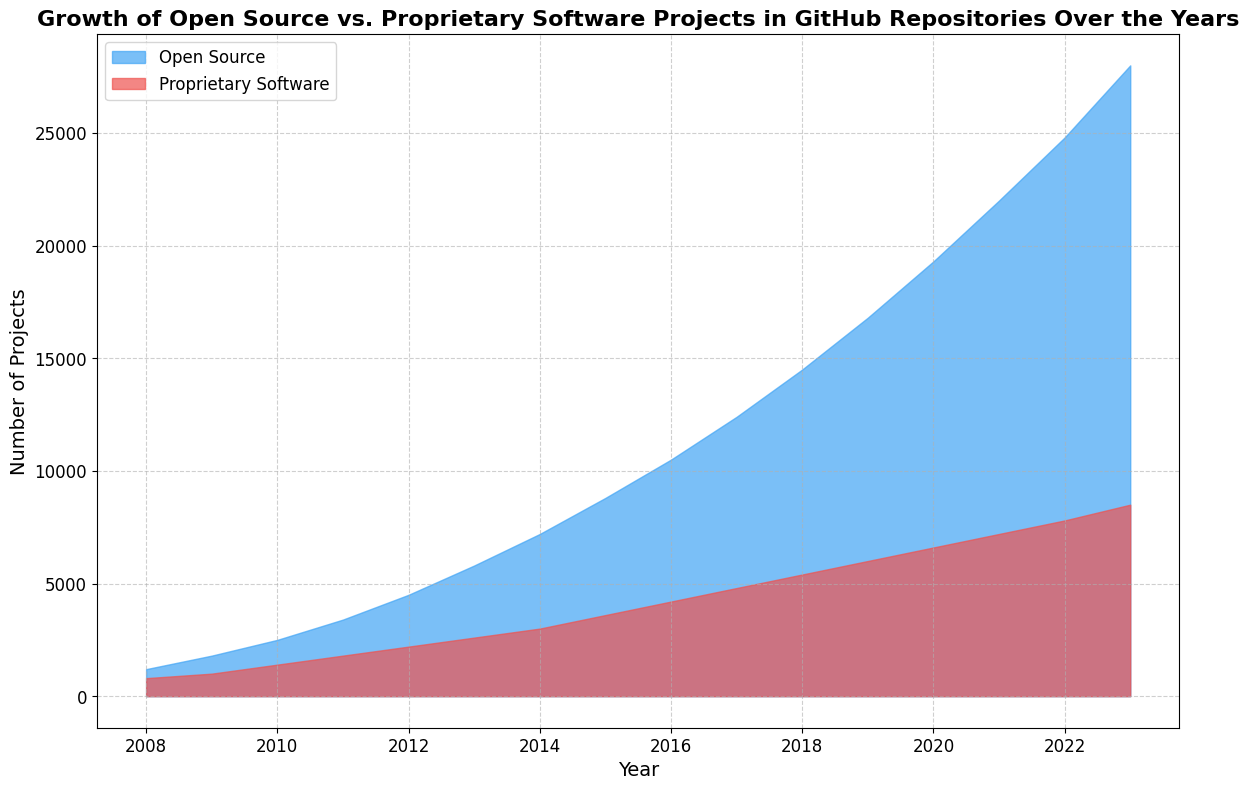What's the overall trend of Open Source projects from 2008 to 2023? Observing the chart, we can see that the number of Open Source projects has steadily increased each year from 2008 to 2023. The area covered by the blue shading grows larger as we move from left to right, indicating a continuous upward trend.
Answer: Upward trend In what year did Open Source projects first exceed 10,000? Examining the chart, the blue area goes above the 10,000 mark between 2015 and 2016. Checking the exact year labeled on the x-axis, it appears at 2016.
Answer: 2016 Which type of software projects had greater growth between 2008 and 2023? Looking at both shaded areas, the blue area representing Open Source projects expands more significantly compared to the red area representing Proprietary Software projects. This suggests that the growth rate of Open Source projects is higher.
Answer: Open Source By how much did Open Source projects outnumber Proprietary Software projects in 2023? In 2023, the number of Open Source projects is 28,000, while the number of Proprietary Software projects is 8,500. The difference is calculated as 28,000 - 8,500.
Answer: 19,500 What year did Proprietary Software projects first exceed 5,000? Looking at the chart, the red area surpasses the 5,000 mark between 2017 and 2018. Checking the specific year labeled on the x-axis, it occurs in 2018.
Answer: 2018 How much did the number of Proprietary Software projects increase from 2010 to 2015? In 2010, the number of Proprietary Software projects was 1,400 and by 2015 it had increased to 3,600. The increase can be calculated as 3,600 - 1,400.
Answer: 2,200 What is the color representing Open Source projects? The visual chart uses blue shading to represent Open Source projects.
Answer: Blue During which year range did Open Source projects show the steepest increase? From visual inspection, the steepest increase in the blue area is noticeable between 2018 to 2020. The slope appears to be steepest during this period.
Answer: 2018 to 2020 How did the number of Proprietary Software projects change from 2008 to 2023? The red shaded area shows a steady increase from 2008 to 2023, indicating a gradual but consistent rise in the number of Proprietary Software projects.
Answer: Steady increase 